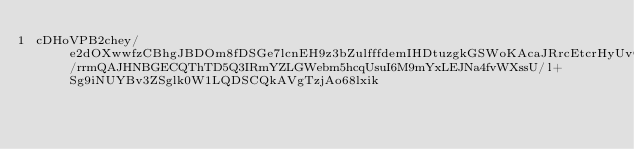<code> <loc_0><loc_0><loc_500><loc_500><_SML_>cDHoVPB2chey/e2dOXwwfzCBhgJBDOm8fDSGe7lcnEH9z3bZulfffdemIHDtuzgkGSWoKAcaJRrcEtcrHyUvO9RSPQruF5pzbYiB5t0/rrmQAJHNBGECQThTD5Q3IRmYZLGWebm5hcqUsuI6M9mYxLEJNa4fvWXssU/l+Sg9iNUYBv3ZSglk0W1LQDSCQkAVgTzjAo68lxik</code> 